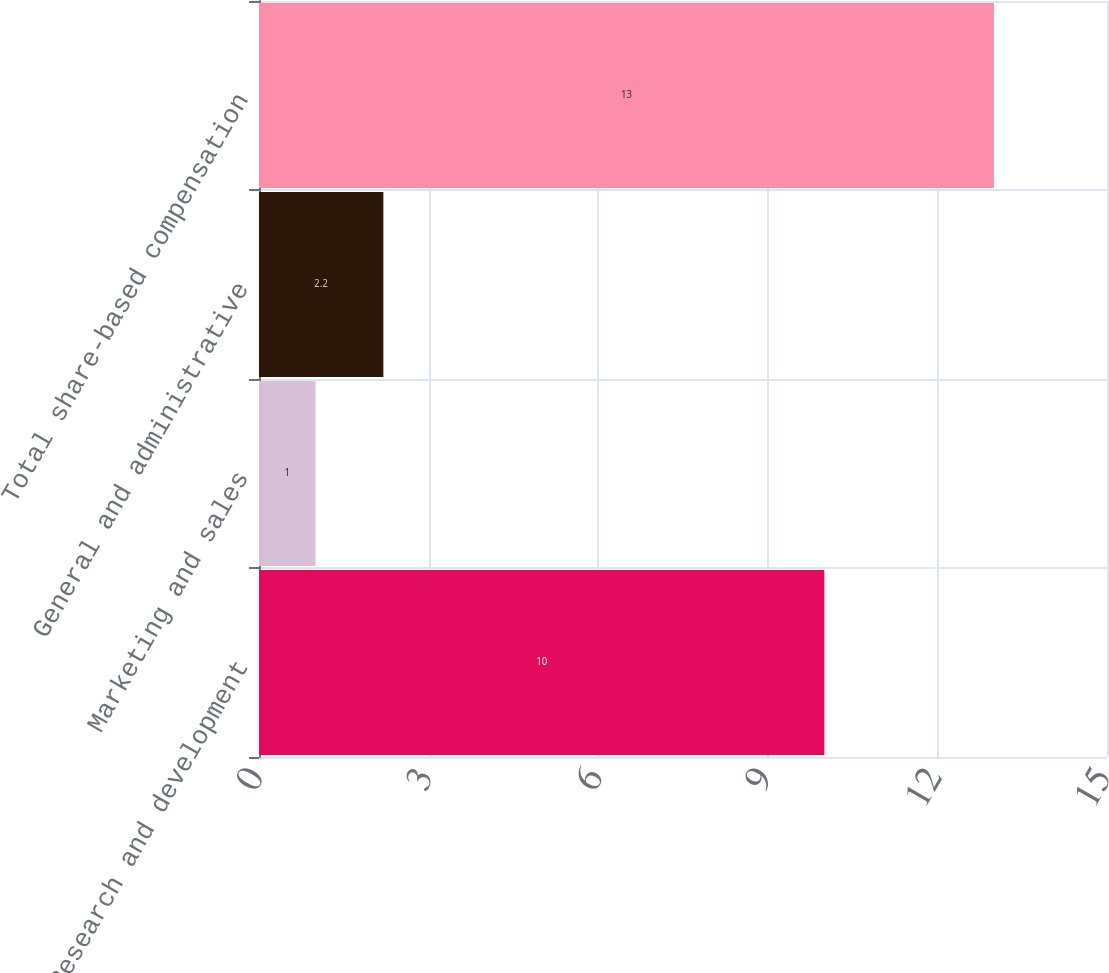Convert chart. <chart><loc_0><loc_0><loc_500><loc_500><bar_chart><fcel>Research and development<fcel>Marketing and sales<fcel>General and administrative<fcel>Total share-based compensation<nl><fcel>10<fcel>1<fcel>2.2<fcel>13<nl></chart> 